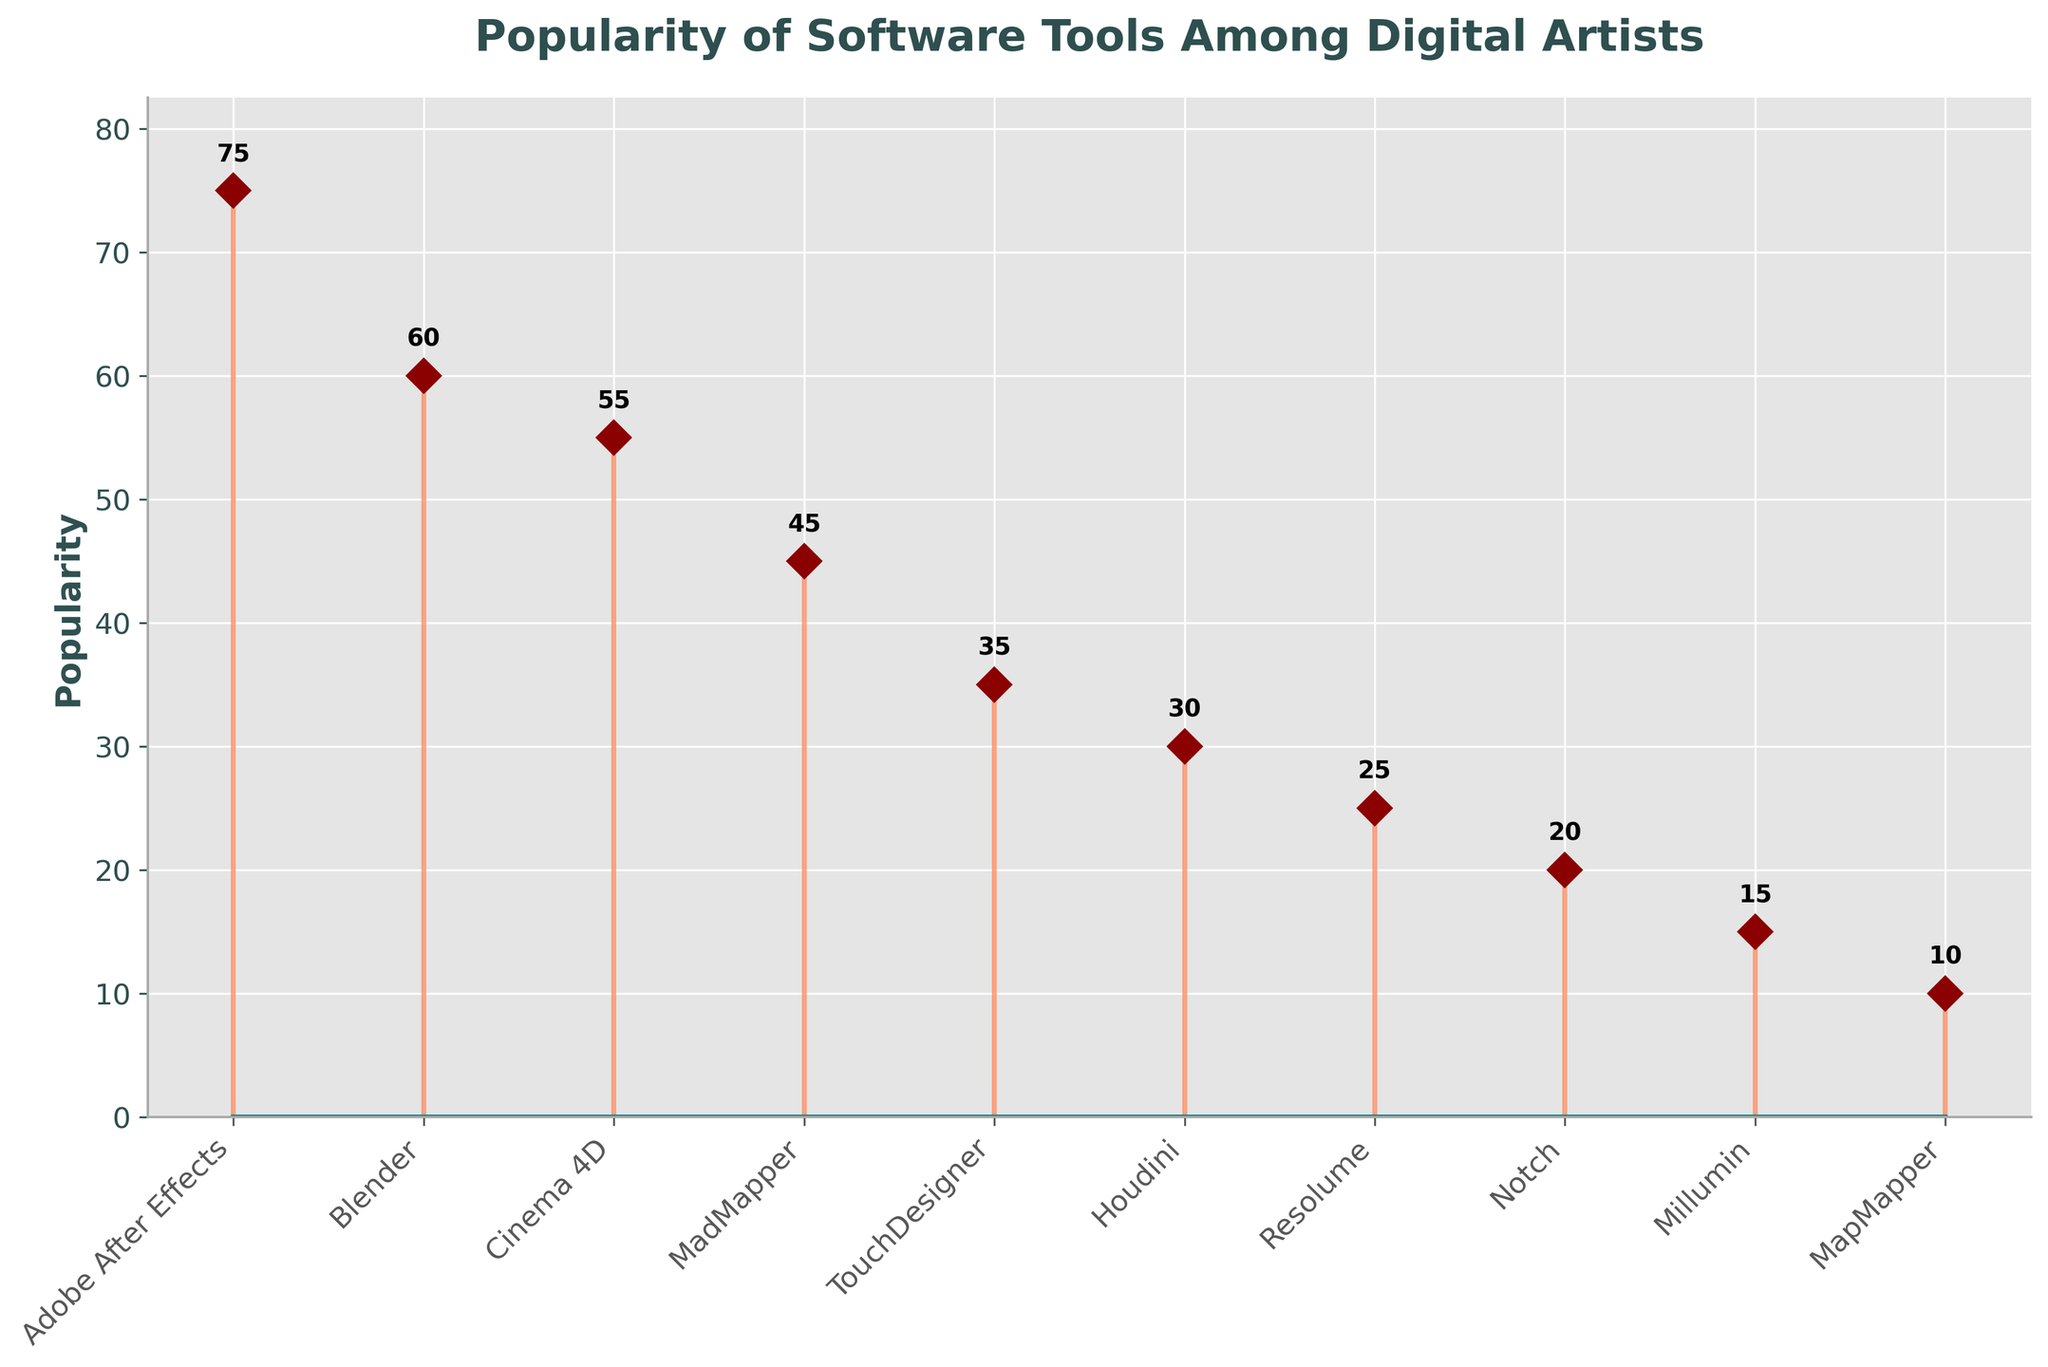How many software tools are listed in the plot? Count all the entries plotted on the x-axis to determine the number of software tools included. There are 10 software tools from "Adobe After Effects" to "MapMapper".
Answer: 10 Which software tool is the most popular among digital artists? Identify the software tool with the highest bar/stem. "Adobe After Effects" has the highest popularity value of 75.
Answer: Adobe After Effects How much more popular is Blender than Cinema 4D? Subtract the popularity value of Cinema 4D from Blender. Blender has a popularity of 60, and Cinema 4D has 55, so the difference is 60 - 55 = 5.
Answer: 5 What is the total popularity of MadMapper, TouchDesigner, and Houdini combined? Add the popularity values of MadMapper, TouchDesigner, and Houdini. MadMapper is 45, TouchDesigner is 35, and Houdini is 30. So, the total is 45 + 35 + 30 = 110.
Answer: 110 Which software tools have a popularity lower than 30? Identify the software tools with a popularity value less than 30. They are "Resolume" (25), "Notch" (20), "Millumin" (15), and "MapMapper" (10).
Answer: Resolume, Notch, Millumin, MapMapper What is the average popularity of the top three most popular software tools? First, identify the top three most popular tools: Adobe After Effects (75), Blender (60), and Cinema 4D (55). Calculate the average of these values: (75 + 60 + 55) / 3 = 63.33.
Answer: 63.33 What is the popularity range (difference between the highest and the lowest popularity values) in the plot? Subtract the lowest popularity value from the highest popularity value. The highest is Adobe After Effects with 75, and the lowest is MapMapper with 10, so the range is 75 - 10 = 65.
Answer: 65 Are there more software tools with a popularity higher than 40 or lower than 40? Count the number of software tools with popularity higher than 40 and those with popularity lower than 40. Higher than 40: Adobe After Effects (75), Blender (60), Cinema 4D (55), MadMapper (45) - total 4. Lower than 40: TouchDesigner (35), Houdini (30), Resolume (25), Notch (20), Millumin (15), MapMapper (10) - total 6.
Answer: Lower than 40 What color are the stem lines in the plot? Observe the color of the vertical lines connecting the data points to the baseline. The stem lines are coral in color.
Answer: Coral 